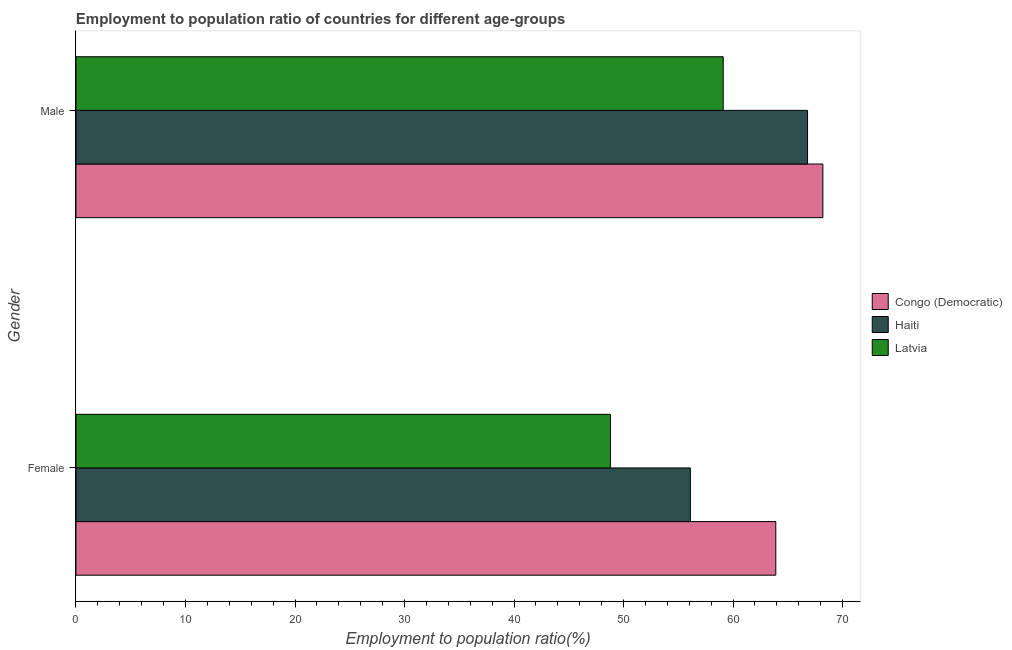How many different coloured bars are there?
Give a very brief answer. 3. How many groups of bars are there?
Make the answer very short. 2. How many bars are there on the 1st tick from the bottom?
Ensure brevity in your answer.  3. What is the employment to population ratio(male) in Haiti?
Your answer should be compact. 66.8. Across all countries, what is the maximum employment to population ratio(male)?
Your answer should be very brief. 68.2. Across all countries, what is the minimum employment to population ratio(male)?
Your answer should be compact. 59.1. In which country was the employment to population ratio(female) maximum?
Make the answer very short. Congo (Democratic). In which country was the employment to population ratio(female) minimum?
Your response must be concise. Latvia. What is the total employment to population ratio(female) in the graph?
Offer a very short reply. 168.8. What is the difference between the employment to population ratio(male) in Congo (Democratic) and that in Haiti?
Give a very brief answer. 1.4. What is the difference between the employment to population ratio(male) in Congo (Democratic) and the employment to population ratio(female) in Haiti?
Offer a very short reply. 12.1. What is the average employment to population ratio(female) per country?
Ensure brevity in your answer.  56.27. What is the difference between the employment to population ratio(female) and employment to population ratio(male) in Congo (Democratic)?
Ensure brevity in your answer.  -4.3. What is the ratio of the employment to population ratio(female) in Congo (Democratic) to that in Haiti?
Your answer should be compact. 1.14. What does the 2nd bar from the top in Female represents?
Keep it short and to the point. Haiti. What does the 3rd bar from the bottom in Male represents?
Keep it short and to the point. Latvia. Are all the bars in the graph horizontal?
Offer a terse response. Yes. What is the difference between two consecutive major ticks on the X-axis?
Make the answer very short. 10. Are the values on the major ticks of X-axis written in scientific E-notation?
Offer a terse response. No. Does the graph contain any zero values?
Provide a succinct answer. No. What is the title of the graph?
Provide a short and direct response. Employment to population ratio of countries for different age-groups. Does "Mozambique" appear as one of the legend labels in the graph?
Your response must be concise. No. What is the label or title of the Y-axis?
Give a very brief answer. Gender. What is the Employment to population ratio(%) in Congo (Democratic) in Female?
Your response must be concise. 63.9. What is the Employment to population ratio(%) in Haiti in Female?
Ensure brevity in your answer.  56.1. What is the Employment to population ratio(%) of Latvia in Female?
Provide a succinct answer. 48.8. What is the Employment to population ratio(%) of Congo (Democratic) in Male?
Your answer should be compact. 68.2. What is the Employment to population ratio(%) in Haiti in Male?
Provide a short and direct response. 66.8. What is the Employment to population ratio(%) of Latvia in Male?
Offer a very short reply. 59.1. Across all Gender, what is the maximum Employment to population ratio(%) of Congo (Democratic)?
Offer a terse response. 68.2. Across all Gender, what is the maximum Employment to population ratio(%) in Haiti?
Keep it short and to the point. 66.8. Across all Gender, what is the maximum Employment to population ratio(%) in Latvia?
Your response must be concise. 59.1. Across all Gender, what is the minimum Employment to population ratio(%) in Congo (Democratic)?
Provide a short and direct response. 63.9. Across all Gender, what is the minimum Employment to population ratio(%) of Haiti?
Your answer should be very brief. 56.1. Across all Gender, what is the minimum Employment to population ratio(%) of Latvia?
Provide a succinct answer. 48.8. What is the total Employment to population ratio(%) in Congo (Democratic) in the graph?
Give a very brief answer. 132.1. What is the total Employment to population ratio(%) in Haiti in the graph?
Offer a terse response. 122.9. What is the total Employment to population ratio(%) in Latvia in the graph?
Keep it short and to the point. 107.9. What is the difference between the Employment to population ratio(%) of Congo (Democratic) in Female and that in Male?
Your response must be concise. -4.3. What is the average Employment to population ratio(%) of Congo (Democratic) per Gender?
Offer a very short reply. 66.05. What is the average Employment to population ratio(%) in Haiti per Gender?
Your answer should be compact. 61.45. What is the average Employment to population ratio(%) in Latvia per Gender?
Your response must be concise. 53.95. What is the difference between the Employment to population ratio(%) of Congo (Democratic) and Employment to population ratio(%) of Haiti in Female?
Give a very brief answer. 7.8. What is the difference between the Employment to population ratio(%) in Congo (Democratic) and Employment to population ratio(%) in Latvia in Female?
Your answer should be very brief. 15.1. What is the ratio of the Employment to population ratio(%) of Congo (Democratic) in Female to that in Male?
Make the answer very short. 0.94. What is the ratio of the Employment to population ratio(%) of Haiti in Female to that in Male?
Your response must be concise. 0.84. What is the ratio of the Employment to population ratio(%) in Latvia in Female to that in Male?
Your answer should be very brief. 0.83. What is the difference between the highest and the second highest Employment to population ratio(%) in Congo (Democratic)?
Your response must be concise. 4.3. What is the difference between the highest and the second highest Employment to population ratio(%) in Haiti?
Provide a short and direct response. 10.7. What is the difference between the highest and the second highest Employment to population ratio(%) of Latvia?
Offer a very short reply. 10.3. What is the difference between the highest and the lowest Employment to population ratio(%) in Haiti?
Provide a succinct answer. 10.7. What is the difference between the highest and the lowest Employment to population ratio(%) in Latvia?
Offer a terse response. 10.3. 